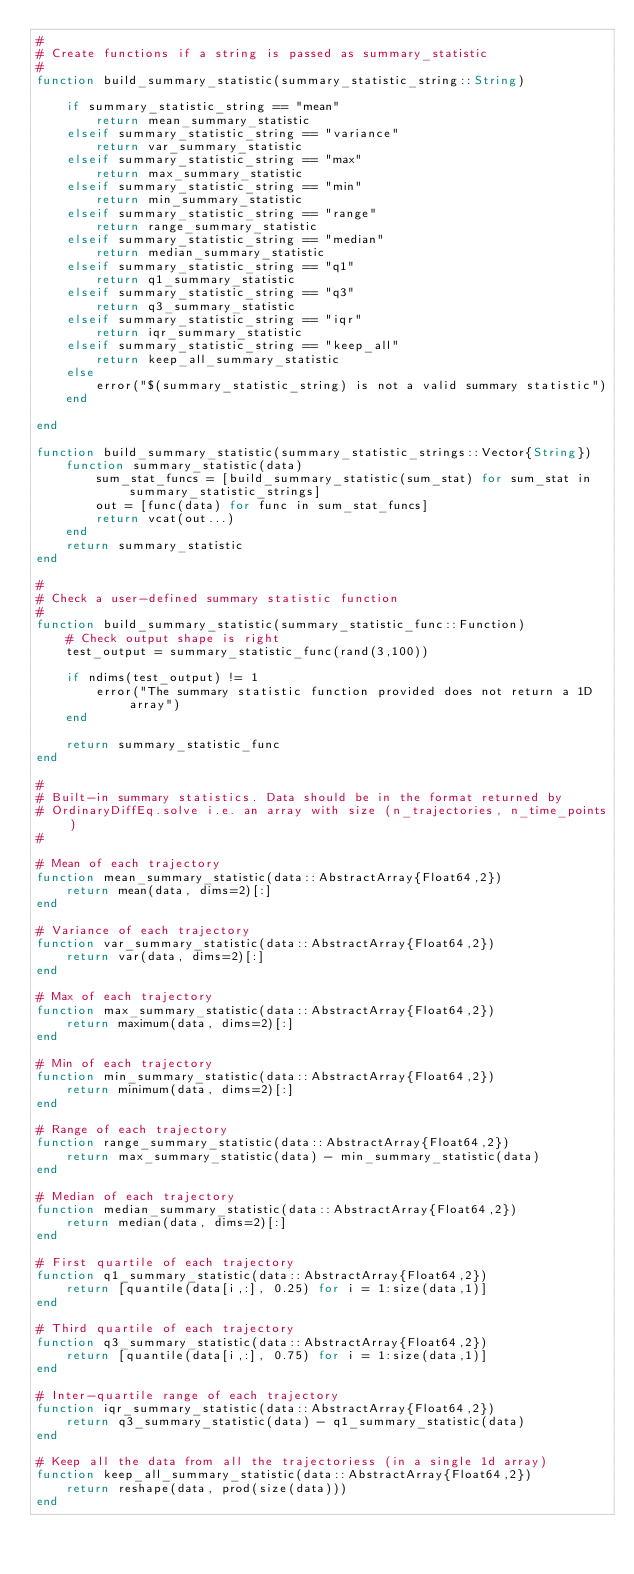Convert code to text. <code><loc_0><loc_0><loc_500><loc_500><_Julia_>#
# Create functions if a string is passed as summary_statistic
#
function build_summary_statistic(summary_statistic_string::String)

    if summary_statistic_string == "mean"
        return mean_summary_statistic
    elseif summary_statistic_string == "variance"
        return var_summary_statistic
    elseif summary_statistic_string == "max"
        return max_summary_statistic
    elseif summary_statistic_string == "min"
        return min_summary_statistic
    elseif summary_statistic_string == "range"
        return range_summary_statistic
    elseif summary_statistic_string == "median"
        return median_summary_statistic
    elseif summary_statistic_string == "q1"
        return q1_summary_statistic
    elseif summary_statistic_string == "q3"
        return q3_summary_statistic
    elseif summary_statistic_string == "iqr"
        return iqr_summary_statistic
    elseif summary_statistic_string == "keep_all"
        return keep_all_summary_statistic
    else
        error("$(summary_statistic_string) is not a valid summary statistic")
    end

end

function build_summary_statistic(summary_statistic_strings::Vector{String})
    function summary_statistic(data)
        sum_stat_funcs = [build_summary_statistic(sum_stat) for sum_stat in summary_statistic_strings]
        out = [func(data) for func in sum_stat_funcs]
        return vcat(out...)
    end
    return summary_statistic
end

#
# Check a user-defined summary statistic function
#
function build_summary_statistic(summary_statistic_func::Function)
    # Check output shape is right
    test_output = summary_statistic_func(rand(3,100))

    if ndims(test_output) != 1
        error("The summary statistic function provided does not return a 1D array")
    end

    return summary_statistic_func
end

#
# Built-in summary statistics. Data should be in the format returned by
# OrdinaryDiffEq.solve i.e. an array with size (n_trajectories, n_time_points)
#

# Mean of each trajectory
function mean_summary_statistic(data::AbstractArray{Float64,2})
    return mean(data, dims=2)[:]
end

# Variance of each trajectory
function var_summary_statistic(data::AbstractArray{Float64,2})
    return var(data, dims=2)[:]
end

# Max of each trajectory
function max_summary_statistic(data::AbstractArray{Float64,2})
    return maximum(data, dims=2)[:]
end

# Min of each trajectory
function min_summary_statistic(data::AbstractArray{Float64,2})
    return minimum(data, dims=2)[:]
end

# Range of each trajectory
function range_summary_statistic(data::AbstractArray{Float64,2})
    return max_summary_statistic(data) - min_summary_statistic(data)
end

# Median of each trajectory
function median_summary_statistic(data::AbstractArray{Float64,2})
    return median(data, dims=2)[:]
end

# First quartile of each trajectory
function q1_summary_statistic(data::AbstractArray{Float64,2})
    return [quantile(data[i,:], 0.25) for i = 1:size(data,1)]
end

# Third quartile of each trajectory
function q3_summary_statistic(data::AbstractArray{Float64,2})
    return [quantile(data[i,:], 0.75) for i = 1:size(data,1)]
end

# Inter-quartile range of each trajectory
function iqr_summary_statistic(data::AbstractArray{Float64,2})
    return q3_summary_statistic(data) - q1_summary_statistic(data)
end

# Keep all the data from all the trajectoriess (in a single 1d array)
function keep_all_summary_statistic(data::AbstractArray{Float64,2})
    return reshape(data, prod(size(data)))
end
</code> 